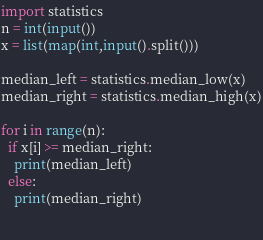<code> <loc_0><loc_0><loc_500><loc_500><_Python_>import statistics
n = int(input())
x = list(map(int,input().split()))

median_left = statistics.median_low(x)
median_right = statistics.median_high(x)

for i in range(n):
  if x[i] >= median_right:
    print(median_left)
  else:
    print(median_right)

  </code> 